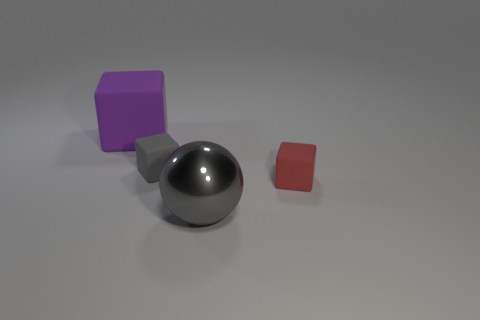Add 2 small brown metal cubes. How many objects exist? 6 Subtract all spheres. How many objects are left? 3 Add 3 big blue things. How many big blue things exist? 3 Subtract 1 red cubes. How many objects are left? 3 Subtract all large cubes. Subtract all purple things. How many objects are left? 2 Add 2 shiny things. How many shiny things are left? 3 